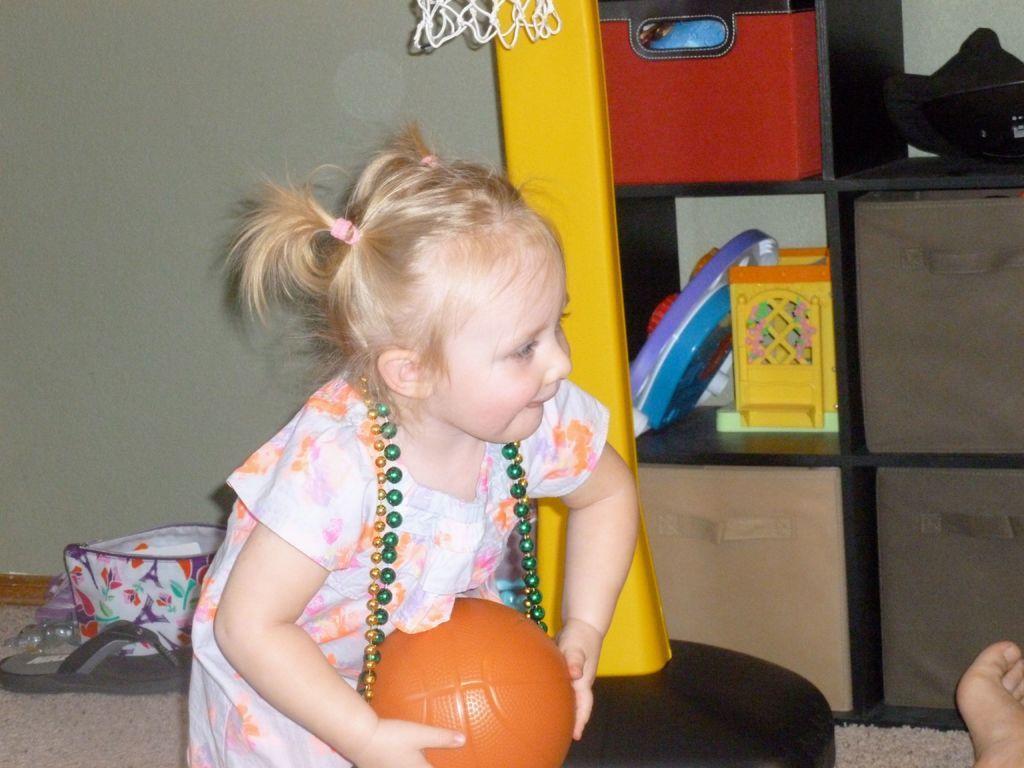How would you summarize this image in a sentence or two? In this image I can see a girl is holding a ball. Here I can see some objects and a footwear 